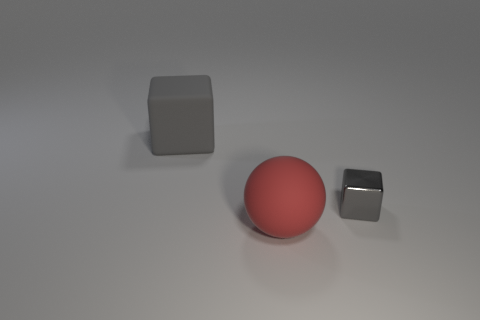Is the number of small green cylinders less than the number of balls?
Keep it short and to the point. Yes. Are there any other things that are the same color as the large block?
Your answer should be compact. Yes. The big object that is the same material as the large ball is what shape?
Offer a terse response. Cube. There is a rubber thing that is left of the large red object that is to the left of the tiny block; what number of large matte objects are in front of it?
Offer a terse response. 1. There is a object that is behind the big rubber sphere and in front of the big matte block; what shape is it?
Your response must be concise. Cube. Are there fewer things that are on the right side of the large matte ball than big cyan metallic balls?
Provide a short and direct response. No. How many big things are either gray things or shiny blocks?
Your response must be concise. 1. The rubber sphere is what size?
Keep it short and to the point. Large. Are there any other things that are the same material as the ball?
Your answer should be compact. Yes. There is a big gray block; how many large gray cubes are left of it?
Make the answer very short. 0. 